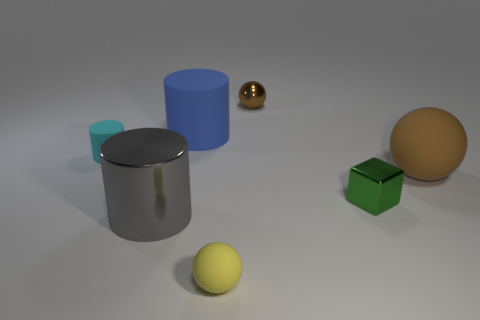What number of brown rubber spheres are there?
Provide a short and direct response. 1. There is a small matte object that is in front of the rubber ball that is behind the tiny yellow sphere; what is its color?
Your answer should be very brief. Yellow. What is the color of the other rubber object that is the same size as the yellow thing?
Your answer should be very brief. Cyan. Is there a tiny ball of the same color as the small block?
Your answer should be compact. No. Is there a tiny green block?
Offer a terse response. Yes. What is the shape of the tiny object to the left of the big blue object?
Ensure brevity in your answer.  Cylinder. What number of tiny things are behind the big sphere and left of the small brown metal thing?
Give a very brief answer. 1. What number of other things are the same size as the cyan thing?
Make the answer very short. 3. There is a brown thing on the left side of the green thing; is it the same shape as the small matte object that is in front of the small matte cylinder?
Ensure brevity in your answer.  Yes. What number of things are either small gray matte balls or tiny balls that are in front of the tiny cyan object?
Provide a succinct answer. 1. 